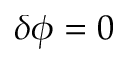Convert formula to latex. <formula><loc_0><loc_0><loc_500><loc_500>\delta \phi = 0</formula> 